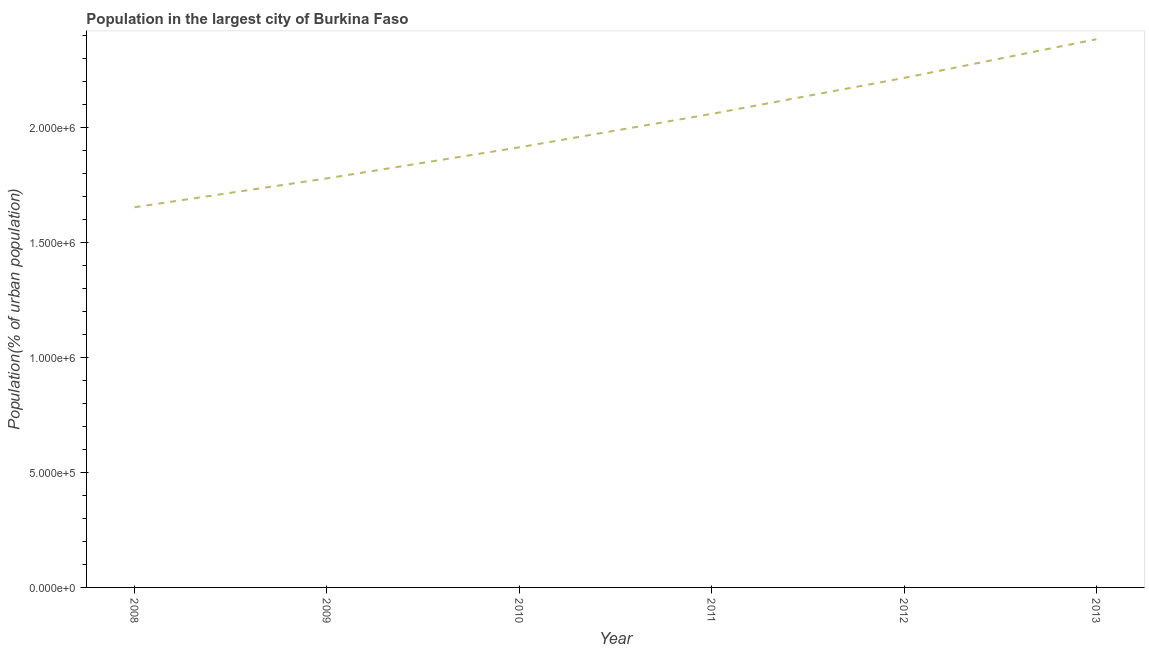What is the population in largest city in 2013?
Offer a terse response. 2.38e+06. Across all years, what is the maximum population in largest city?
Ensure brevity in your answer.  2.38e+06. Across all years, what is the minimum population in largest city?
Make the answer very short. 1.65e+06. In which year was the population in largest city maximum?
Make the answer very short. 2013. What is the sum of the population in largest city?
Offer a very short reply. 1.20e+07. What is the difference between the population in largest city in 2011 and 2012?
Provide a short and direct response. -1.56e+05. What is the average population in largest city per year?
Make the answer very short. 2.00e+06. What is the median population in largest city?
Provide a short and direct response. 1.99e+06. Do a majority of the years between 2013 and 2008 (inclusive) have population in largest city greater than 1900000 %?
Keep it short and to the point. Yes. What is the ratio of the population in largest city in 2010 to that in 2012?
Offer a terse response. 0.86. Is the population in largest city in 2010 less than that in 2011?
Your answer should be compact. Yes. Is the difference between the population in largest city in 2012 and 2013 greater than the difference between any two years?
Provide a succinct answer. No. What is the difference between the highest and the second highest population in largest city?
Provide a short and direct response. 1.68e+05. What is the difference between the highest and the lowest population in largest city?
Provide a succinct answer. 7.31e+05. How many lines are there?
Keep it short and to the point. 1. How many years are there in the graph?
Provide a short and direct response. 6. Does the graph contain any zero values?
Your answer should be compact. No. Does the graph contain grids?
Ensure brevity in your answer.  No. What is the title of the graph?
Offer a very short reply. Population in the largest city of Burkina Faso. What is the label or title of the Y-axis?
Give a very brief answer. Population(% of urban population). What is the Population(% of urban population) of 2008?
Keep it short and to the point. 1.65e+06. What is the Population(% of urban population) of 2009?
Your answer should be very brief. 1.78e+06. What is the Population(% of urban population) in 2010?
Offer a terse response. 1.91e+06. What is the Population(% of urban population) of 2011?
Ensure brevity in your answer.  2.06e+06. What is the Population(% of urban population) of 2012?
Your answer should be compact. 2.22e+06. What is the Population(% of urban population) in 2013?
Provide a succinct answer. 2.38e+06. What is the difference between the Population(% of urban population) in 2008 and 2009?
Give a very brief answer. -1.26e+05. What is the difference between the Population(% of urban population) in 2008 and 2010?
Offer a very short reply. -2.61e+05. What is the difference between the Population(% of urban population) in 2008 and 2011?
Ensure brevity in your answer.  -4.06e+05. What is the difference between the Population(% of urban population) in 2008 and 2012?
Make the answer very short. -5.62e+05. What is the difference between the Population(% of urban population) in 2008 and 2013?
Ensure brevity in your answer.  -7.31e+05. What is the difference between the Population(% of urban population) in 2009 and 2010?
Provide a short and direct response. -1.35e+05. What is the difference between the Population(% of urban population) in 2009 and 2011?
Provide a short and direct response. -2.80e+05. What is the difference between the Population(% of urban population) in 2009 and 2012?
Your response must be concise. -4.37e+05. What is the difference between the Population(% of urban population) in 2009 and 2013?
Offer a terse response. -6.05e+05. What is the difference between the Population(% of urban population) in 2010 and 2011?
Your response must be concise. -1.45e+05. What is the difference between the Population(% of urban population) in 2010 and 2012?
Give a very brief answer. -3.02e+05. What is the difference between the Population(% of urban population) in 2010 and 2013?
Offer a very short reply. -4.70e+05. What is the difference between the Population(% of urban population) in 2011 and 2012?
Your answer should be very brief. -1.56e+05. What is the difference between the Population(% of urban population) in 2011 and 2013?
Offer a very short reply. -3.25e+05. What is the difference between the Population(% of urban population) in 2012 and 2013?
Your response must be concise. -1.68e+05. What is the ratio of the Population(% of urban population) in 2008 to that in 2009?
Offer a very short reply. 0.93. What is the ratio of the Population(% of urban population) in 2008 to that in 2010?
Give a very brief answer. 0.86. What is the ratio of the Population(% of urban population) in 2008 to that in 2011?
Your answer should be very brief. 0.8. What is the ratio of the Population(% of urban population) in 2008 to that in 2012?
Offer a very short reply. 0.75. What is the ratio of the Population(% of urban population) in 2008 to that in 2013?
Provide a short and direct response. 0.69. What is the ratio of the Population(% of urban population) in 2009 to that in 2010?
Provide a succinct answer. 0.93. What is the ratio of the Population(% of urban population) in 2009 to that in 2011?
Your answer should be very brief. 0.86. What is the ratio of the Population(% of urban population) in 2009 to that in 2012?
Provide a short and direct response. 0.8. What is the ratio of the Population(% of urban population) in 2009 to that in 2013?
Offer a terse response. 0.75. What is the ratio of the Population(% of urban population) in 2010 to that in 2011?
Your response must be concise. 0.93. What is the ratio of the Population(% of urban population) in 2010 to that in 2012?
Your answer should be compact. 0.86. What is the ratio of the Population(% of urban population) in 2010 to that in 2013?
Your answer should be very brief. 0.8. What is the ratio of the Population(% of urban population) in 2011 to that in 2012?
Keep it short and to the point. 0.93. What is the ratio of the Population(% of urban population) in 2011 to that in 2013?
Your answer should be very brief. 0.86. What is the ratio of the Population(% of urban population) in 2012 to that in 2013?
Keep it short and to the point. 0.93. 